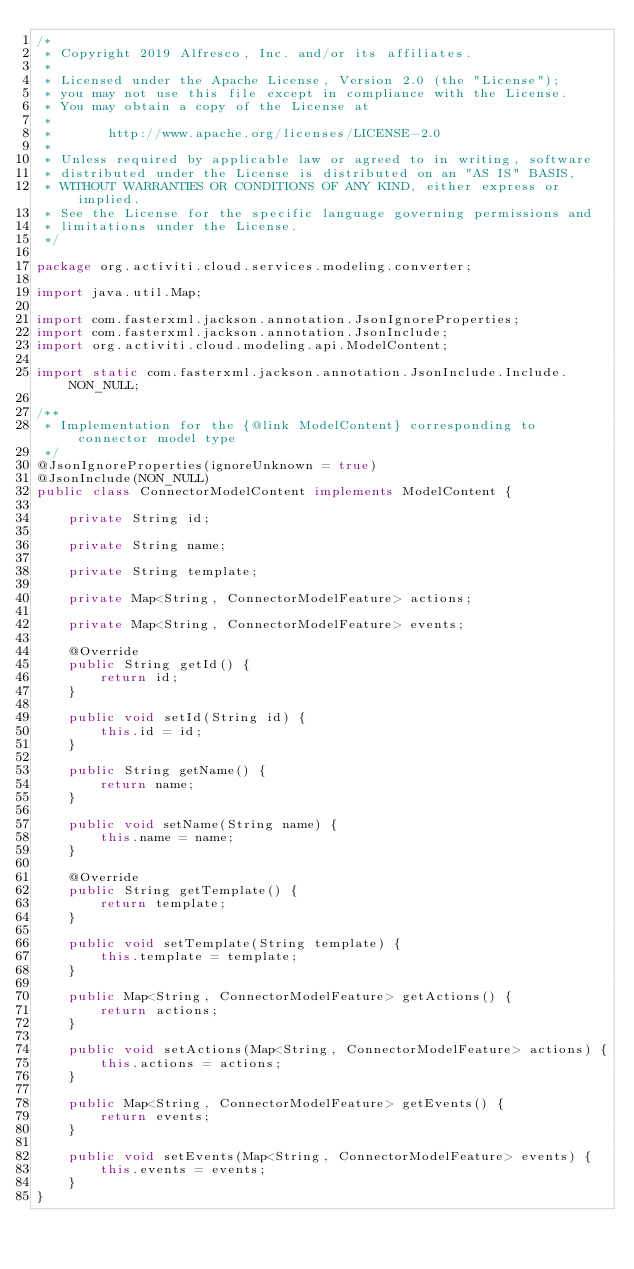Convert code to text. <code><loc_0><loc_0><loc_500><loc_500><_Java_>/*
 * Copyright 2019 Alfresco, Inc. and/or its affiliates.
 *
 * Licensed under the Apache License, Version 2.0 (the "License");
 * you may not use this file except in compliance with the License.
 * You may obtain a copy of the License at
 *
 *       http://www.apache.org/licenses/LICENSE-2.0
 *
 * Unless required by applicable law or agreed to in writing, software
 * distributed under the License is distributed on an "AS IS" BASIS,
 * WITHOUT WARRANTIES OR CONDITIONS OF ANY KIND, either express or implied.
 * See the License for the specific language governing permissions and
 * limitations under the License.
 */

package org.activiti.cloud.services.modeling.converter;

import java.util.Map;

import com.fasterxml.jackson.annotation.JsonIgnoreProperties;
import com.fasterxml.jackson.annotation.JsonInclude;
import org.activiti.cloud.modeling.api.ModelContent;

import static com.fasterxml.jackson.annotation.JsonInclude.Include.NON_NULL;

/**
 * Implementation for the {@link ModelContent} corresponding to connector model type
 */
@JsonIgnoreProperties(ignoreUnknown = true)
@JsonInclude(NON_NULL)
public class ConnectorModelContent implements ModelContent {

    private String id;

    private String name;

    private String template;

    private Map<String, ConnectorModelFeature> actions;

    private Map<String, ConnectorModelFeature> events;

    @Override
    public String getId() {
        return id;
    }

    public void setId(String id) {
        this.id = id;
    }

    public String getName() {
        return name;
    }

    public void setName(String name) {
        this.name = name;
    }

    @Override
    public String getTemplate() {
        return template;
    }

    public void setTemplate(String template) {
        this.template = template;
    }

    public Map<String, ConnectorModelFeature> getActions() {
        return actions;
    }

    public void setActions(Map<String, ConnectorModelFeature> actions) {
        this.actions = actions;
    }

    public Map<String, ConnectorModelFeature> getEvents() {
        return events;
    }

    public void setEvents(Map<String, ConnectorModelFeature> events) {
        this.events = events;
    }
}
</code> 